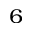<formula> <loc_0><loc_0><loc_500><loc_500>^ { 6 }</formula> 